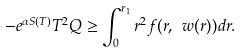<formula> <loc_0><loc_0><loc_500><loc_500>- e ^ { \alpha S ( T ) } T ^ { 2 } Q \geq \int _ { 0 } ^ { r _ { 1 } } r ^ { 2 } f ( r , \ w ( r ) ) d r .</formula> 